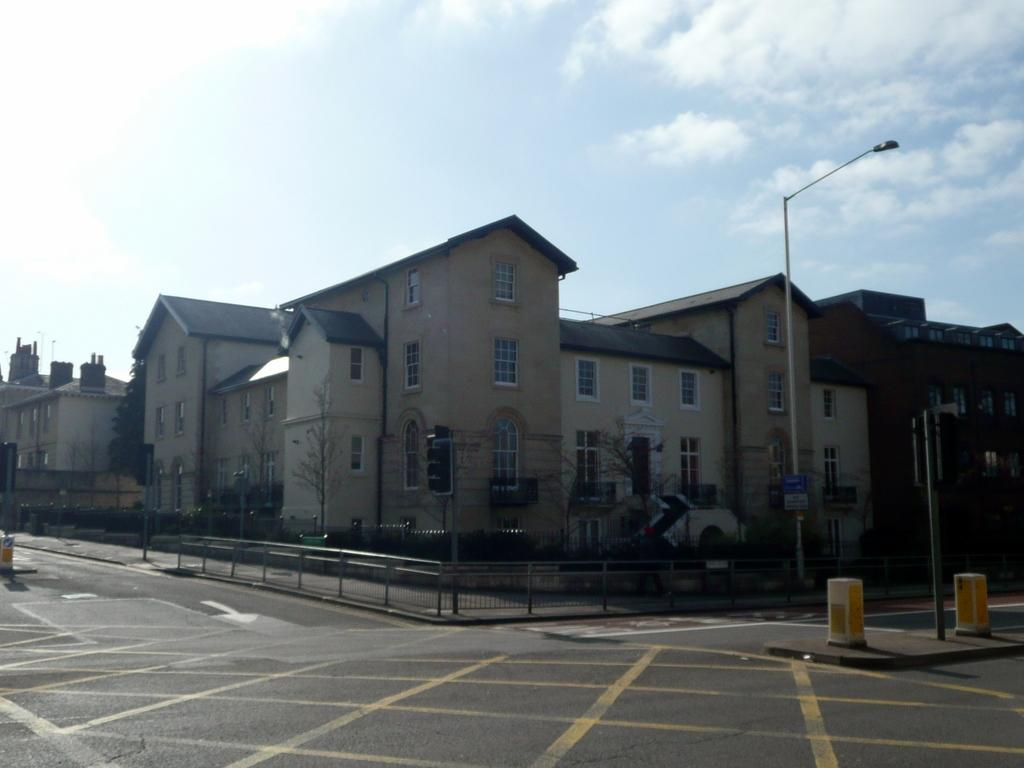What is the main feature of the image? There is a road in the image. What can be seen in the background of the image? In the background, there is a railing, light poles, trees, buildings, and the sky. Can you describe the surroundings of the road? The road is surrounded by a railing, light poles, trees, and buildings. What is the color of the sky in the image? The sky is visible in the background of the image, but the color is not mentioned in the facts. What type of ornament is hanging from the light poles in the image? There is no mention of any ornaments hanging from the light poles in the image. What kind of insurance policy is being advertised on the buildings in the image? There is no indication of any insurance advertisements on the buildings in the image. 